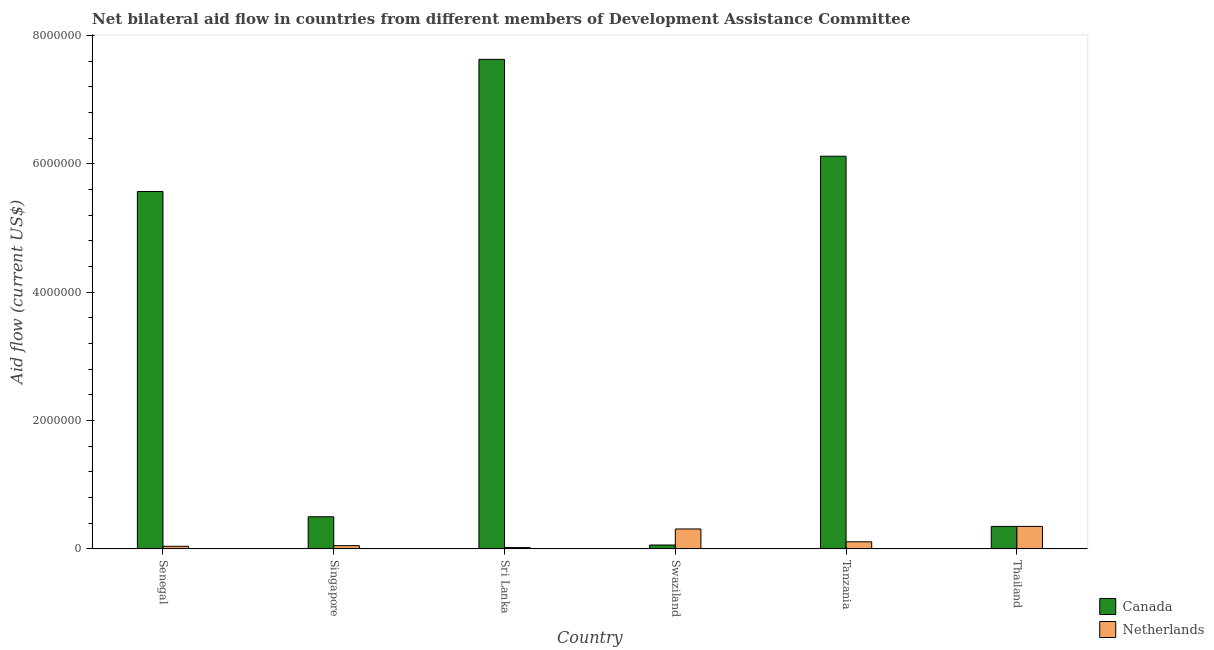How many different coloured bars are there?
Your response must be concise. 2. Are the number of bars on each tick of the X-axis equal?
Keep it short and to the point. Yes. How many bars are there on the 6th tick from the right?
Give a very brief answer. 2. What is the label of the 5th group of bars from the left?
Provide a short and direct response. Tanzania. In how many cases, is the number of bars for a given country not equal to the number of legend labels?
Your answer should be very brief. 0. What is the amount of aid given by canada in Senegal?
Offer a very short reply. 5.57e+06. Across all countries, what is the maximum amount of aid given by netherlands?
Keep it short and to the point. 3.50e+05. Across all countries, what is the minimum amount of aid given by netherlands?
Provide a short and direct response. 2.00e+04. In which country was the amount of aid given by netherlands maximum?
Keep it short and to the point. Thailand. In which country was the amount of aid given by canada minimum?
Your answer should be very brief. Swaziland. What is the total amount of aid given by canada in the graph?
Keep it short and to the point. 2.02e+07. What is the difference between the amount of aid given by canada in Sri Lanka and that in Thailand?
Offer a terse response. 7.28e+06. What is the difference between the amount of aid given by netherlands in Sri Lanka and the amount of aid given by canada in Tanzania?
Offer a terse response. -6.10e+06. What is the average amount of aid given by canada per country?
Your answer should be compact. 3.37e+06. What is the difference between the amount of aid given by canada and amount of aid given by netherlands in Senegal?
Your answer should be very brief. 5.53e+06. In how many countries, is the amount of aid given by netherlands greater than 5200000 US$?
Your response must be concise. 0. What is the ratio of the amount of aid given by canada in Tanzania to that in Thailand?
Offer a terse response. 17.49. Is the amount of aid given by canada in Singapore less than that in Thailand?
Ensure brevity in your answer.  No. What is the difference between the highest and the second highest amount of aid given by netherlands?
Make the answer very short. 4.00e+04. What is the difference between the highest and the lowest amount of aid given by canada?
Provide a short and direct response. 7.57e+06. Is the sum of the amount of aid given by canada in Senegal and Swaziland greater than the maximum amount of aid given by netherlands across all countries?
Your answer should be compact. Yes. What does the 1st bar from the left in Thailand represents?
Give a very brief answer. Canada. What does the 1st bar from the right in Thailand represents?
Provide a short and direct response. Netherlands. How many bars are there?
Your answer should be compact. 12. Are all the bars in the graph horizontal?
Keep it short and to the point. No. How many countries are there in the graph?
Provide a succinct answer. 6. Does the graph contain any zero values?
Your answer should be very brief. No. Where does the legend appear in the graph?
Your response must be concise. Bottom right. How many legend labels are there?
Offer a very short reply. 2. How are the legend labels stacked?
Offer a very short reply. Vertical. What is the title of the graph?
Provide a short and direct response. Net bilateral aid flow in countries from different members of Development Assistance Committee. Does "Total Population" appear as one of the legend labels in the graph?
Offer a terse response. No. What is the label or title of the Y-axis?
Provide a short and direct response. Aid flow (current US$). What is the Aid flow (current US$) in Canada in Senegal?
Give a very brief answer. 5.57e+06. What is the Aid flow (current US$) of Canada in Singapore?
Your answer should be compact. 5.00e+05. What is the Aid flow (current US$) of Canada in Sri Lanka?
Provide a short and direct response. 7.63e+06. What is the Aid flow (current US$) in Canada in Swaziland?
Your response must be concise. 6.00e+04. What is the Aid flow (current US$) in Netherlands in Swaziland?
Offer a very short reply. 3.10e+05. What is the Aid flow (current US$) in Canada in Tanzania?
Keep it short and to the point. 6.12e+06. Across all countries, what is the maximum Aid flow (current US$) of Canada?
Your response must be concise. 7.63e+06. Across all countries, what is the minimum Aid flow (current US$) of Canada?
Make the answer very short. 6.00e+04. What is the total Aid flow (current US$) of Canada in the graph?
Your answer should be compact. 2.02e+07. What is the total Aid flow (current US$) of Netherlands in the graph?
Your answer should be compact. 8.80e+05. What is the difference between the Aid flow (current US$) in Canada in Senegal and that in Singapore?
Provide a short and direct response. 5.07e+06. What is the difference between the Aid flow (current US$) of Netherlands in Senegal and that in Singapore?
Make the answer very short. -10000. What is the difference between the Aid flow (current US$) of Canada in Senegal and that in Sri Lanka?
Provide a short and direct response. -2.06e+06. What is the difference between the Aid flow (current US$) of Canada in Senegal and that in Swaziland?
Provide a short and direct response. 5.51e+06. What is the difference between the Aid flow (current US$) in Canada in Senegal and that in Tanzania?
Your answer should be compact. -5.50e+05. What is the difference between the Aid flow (current US$) of Canada in Senegal and that in Thailand?
Offer a very short reply. 5.22e+06. What is the difference between the Aid flow (current US$) in Netherlands in Senegal and that in Thailand?
Your response must be concise. -3.10e+05. What is the difference between the Aid flow (current US$) of Canada in Singapore and that in Sri Lanka?
Give a very brief answer. -7.13e+06. What is the difference between the Aid flow (current US$) of Canada in Singapore and that in Tanzania?
Ensure brevity in your answer.  -5.62e+06. What is the difference between the Aid flow (current US$) in Canada in Singapore and that in Thailand?
Your answer should be very brief. 1.50e+05. What is the difference between the Aid flow (current US$) of Canada in Sri Lanka and that in Swaziland?
Your answer should be compact. 7.57e+06. What is the difference between the Aid flow (current US$) of Netherlands in Sri Lanka and that in Swaziland?
Your response must be concise. -2.90e+05. What is the difference between the Aid flow (current US$) of Canada in Sri Lanka and that in Tanzania?
Provide a short and direct response. 1.51e+06. What is the difference between the Aid flow (current US$) in Netherlands in Sri Lanka and that in Tanzania?
Provide a short and direct response. -9.00e+04. What is the difference between the Aid flow (current US$) of Canada in Sri Lanka and that in Thailand?
Your response must be concise. 7.28e+06. What is the difference between the Aid flow (current US$) in Netherlands in Sri Lanka and that in Thailand?
Provide a succinct answer. -3.30e+05. What is the difference between the Aid flow (current US$) in Canada in Swaziland and that in Tanzania?
Your answer should be very brief. -6.06e+06. What is the difference between the Aid flow (current US$) in Netherlands in Swaziland and that in Tanzania?
Ensure brevity in your answer.  2.00e+05. What is the difference between the Aid flow (current US$) in Netherlands in Swaziland and that in Thailand?
Ensure brevity in your answer.  -4.00e+04. What is the difference between the Aid flow (current US$) in Canada in Tanzania and that in Thailand?
Give a very brief answer. 5.77e+06. What is the difference between the Aid flow (current US$) of Netherlands in Tanzania and that in Thailand?
Give a very brief answer. -2.40e+05. What is the difference between the Aid flow (current US$) of Canada in Senegal and the Aid flow (current US$) of Netherlands in Singapore?
Give a very brief answer. 5.52e+06. What is the difference between the Aid flow (current US$) in Canada in Senegal and the Aid flow (current US$) in Netherlands in Sri Lanka?
Provide a succinct answer. 5.55e+06. What is the difference between the Aid flow (current US$) in Canada in Senegal and the Aid flow (current US$) in Netherlands in Swaziland?
Make the answer very short. 5.26e+06. What is the difference between the Aid flow (current US$) in Canada in Senegal and the Aid flow (current US$) in Netherlands in Tanzania?
Offer a terse response. 5.46e+06. What is the difference between the Aid flow (current US$) in Canada in Senegal and the Aid flow (current US$) in Netherlands in Thailand?
Keep it short and to the point. 5.22e+06. What is the difference between the Aid flow (current US$) of Canada in Singapore and the Aid flow (current US$) of Netherlands in Swaziland?
Your answer should be very brief. 1.90e+05. What is the difference between the Aid flow (current US$) in Canada in Singapore and the Aid flow (current US$) in Netherlands in Thailand?
Ensure brevity in your answer.  1.50e+05. What is the difference between the Aid flow (current US$) in Canada in Sri Lanka and the Aid flow (current US$) in Netherlands in Swaziland?
Your answer should be compact. 7.32e+06. What is the difference between the Aid flow (current US$) in Canada in Sri Lanka and the Aid flow (current US$) in Netherlands in Tanzania?
Your answer should be compact. 7.52e+06. What is the difference between the Aid flow (current US$) of Canada in Sri Lanka and the Aid flow (current US$) of Netherlands in Thailand?
Ensure brevity in your answer.  7.28e+06. What is the difference between the Aid flow (current US$) of Canada in Swaziland and the Aid flow (current US$) of Netherlands in Tanzania?
Provide a short and direct response. -5.00e+04. What is the difference between the Aid flow (current US$) in Canada in Swaziland and the Aid flow (current US$) in Netherlands in Thailand?
Give a very brief answer. -2.90e+05. What is the difference between the Aid flow (current US$) in Canada in Tanzania and the Aid flow (current US$) in Netherlands in Thailand?
Offer a very short reply. 5.77e+06. What is the average Aid flow (current US$) of Canada per country?
Make the answer very short. 3.37e+06. What is the average Aid flow (current US$) in Netherlands per country?
Ensure brevity in your answer.  1.47e+05. What is the difference between the Aid flow (current US$) of Canada and Aid flow (current US$) of Netherlands in Senegal?
Your answer should be very brief. 5.53e+06. What is the difference between the Aid flow (current US$) in Canada and Aid flow (current US$) in Netherlands in Sri Lanka?
Offer a very short reply. 7.61e+06. What is the difference between the Aid flow (current US$) of Canada and Aid flow (current US$) of Netherlands in Tanzania?
Your response must be concise. 6.01e+06. What is the ratio of the Aid flow (current US$) in Canada in Senegal to that in Singapore?
Make the answer very short. 11.14. What is the ratio of the Aid flow (current US$) of Canada in Senegal to that in Sri Lanka?
Make the answer very short. 0.73. What is the ratio of the Aid flow (current US$) in Netherlands in Senegal to that in Sri Lanka?
Offer a very short reply. 2. What is the ratio of the Aid flow (current US$) of Canada in Senegal to that in Swaziland?
Provide a short and direct response. 92.83. What is the ratio of the Aid flow (current US$) in Netherlands in Senegal to that in Swaziland?
Offer a terse response. 0.13. What is the ratio of the Aid flow (current US$) in Canada in Senegal to that in Tanzania?
Offer a terse response. 0.91. What is the ratio of the Aid flow (current US$) in Netherlands in Senegal to that in Tanzania?
Give a very brief answer. 0.36. What is the ratio of the Aid flow (current US$) in Canada in Senegal to that in Thailand?
Keep it short and to the point. 15.91. What is the ratio of the Aid flow (current US$) of Netherlands in Senegal to that in Thailand?
Give a very brief answer. 0.11. What is the ratio of the Aid flow (current US$) of Canada in Singapore to that in Sri Lanka?
Offer a terse response. 0.07. What is the ratio of the Aid flow (current US$) of Netherlands in Singapore to that in Sri Lanka?
Ensure brevity in your answer.  2.5. What is the ratio of the Aid flow (current US$) in Canada in Singapore to that in Swaziland?
Keep it short and to the point. 8.33. What is the ratio of the Aid flow (current US$) of Netherlands in Singapore to that in Swaziland?
Offer a very short reply. 0.16. What is the ratio of the Aid flow (current US$) in Canada in Singapore to that in Tanzania?
Provide a succinct answer. 0.08. What is the ratio of the Aid flow (current US$) of Netherlands in Singapore to that in Tanzania?
Your answer should be compact. 0.45. What is the ratio of the Aid flow (current US$) of Canada in Singapore to that in Thailand?
Your answer should be compact. 1.43. What is the ratio of the Aid flow (current US$) of Netherlands in Singapore to that in Thailand?
Keep it short and to the point. 0.14. What is the ratio of the Aid flow (current US$) in Canada in Sri Lanka to that in Swaziland?
Ensure brevity in your answer.  127.17. What is the ratio of the Aid flow (current US$) of Netherlands in Sri Lanka to that in Swaziland?
Keep it short and to the point. 0.06. What is the ratio of the Aid flow (current US$) in Canada in Sri Lanka to that in Tanzania?
Offer a very short reply. 1.25. What is the ratio of the Aid flow (current US$) of Netherlands in Sri Lanka to that in Tanzania?
Your answer should be compact. 0.18. What is the ratio of the Aid flow (current US$) of Canada in Sri Lanka to that in Thailand?
Give a very brief answer. 21.8. What is the ratio of the Aid flow (current US$) of Netherlands in Sri Lanka to that in Thailand?
Your response must be concise. 0.06. What is the ratio of the Aid flow (current US$) in Canada in Swaziland to that in Tanzania?
Your answer should be compact. 0.01. What is the ratio of the Aid flow (current US$) of Netherlands in Swaziland to that in Tanzania?
Offer a very short reply. 2.82. What is the ratio of the Aid flow (current US$) of Canada in Swaziland to that in Thailand?
Keep it short and to the point. 0.17. What is the ratio of the Aid flow (current US$) of Netherlands in Swaziland to that in Thailand?
Your answer should be compact. 0.89. What is the ratio of the Aid flow (current US$) of Canada in Tanzania to that in Thailand?
Give a very brief answer. 17.49. What is the ratio of the Aid flow (current US$) of Netherlands in Tanzania to that in Thailand?
Your answer should be very brief. 0.31. What is the difference between the highest and the second highest Aid flow (current US$) in Canada?
Keep it short and to the point. 1.51e+06. What is the difference between the highest and the lowest Aid flow (current US$) of Canada?
Provide a succinct answer. 7.57e+06. 